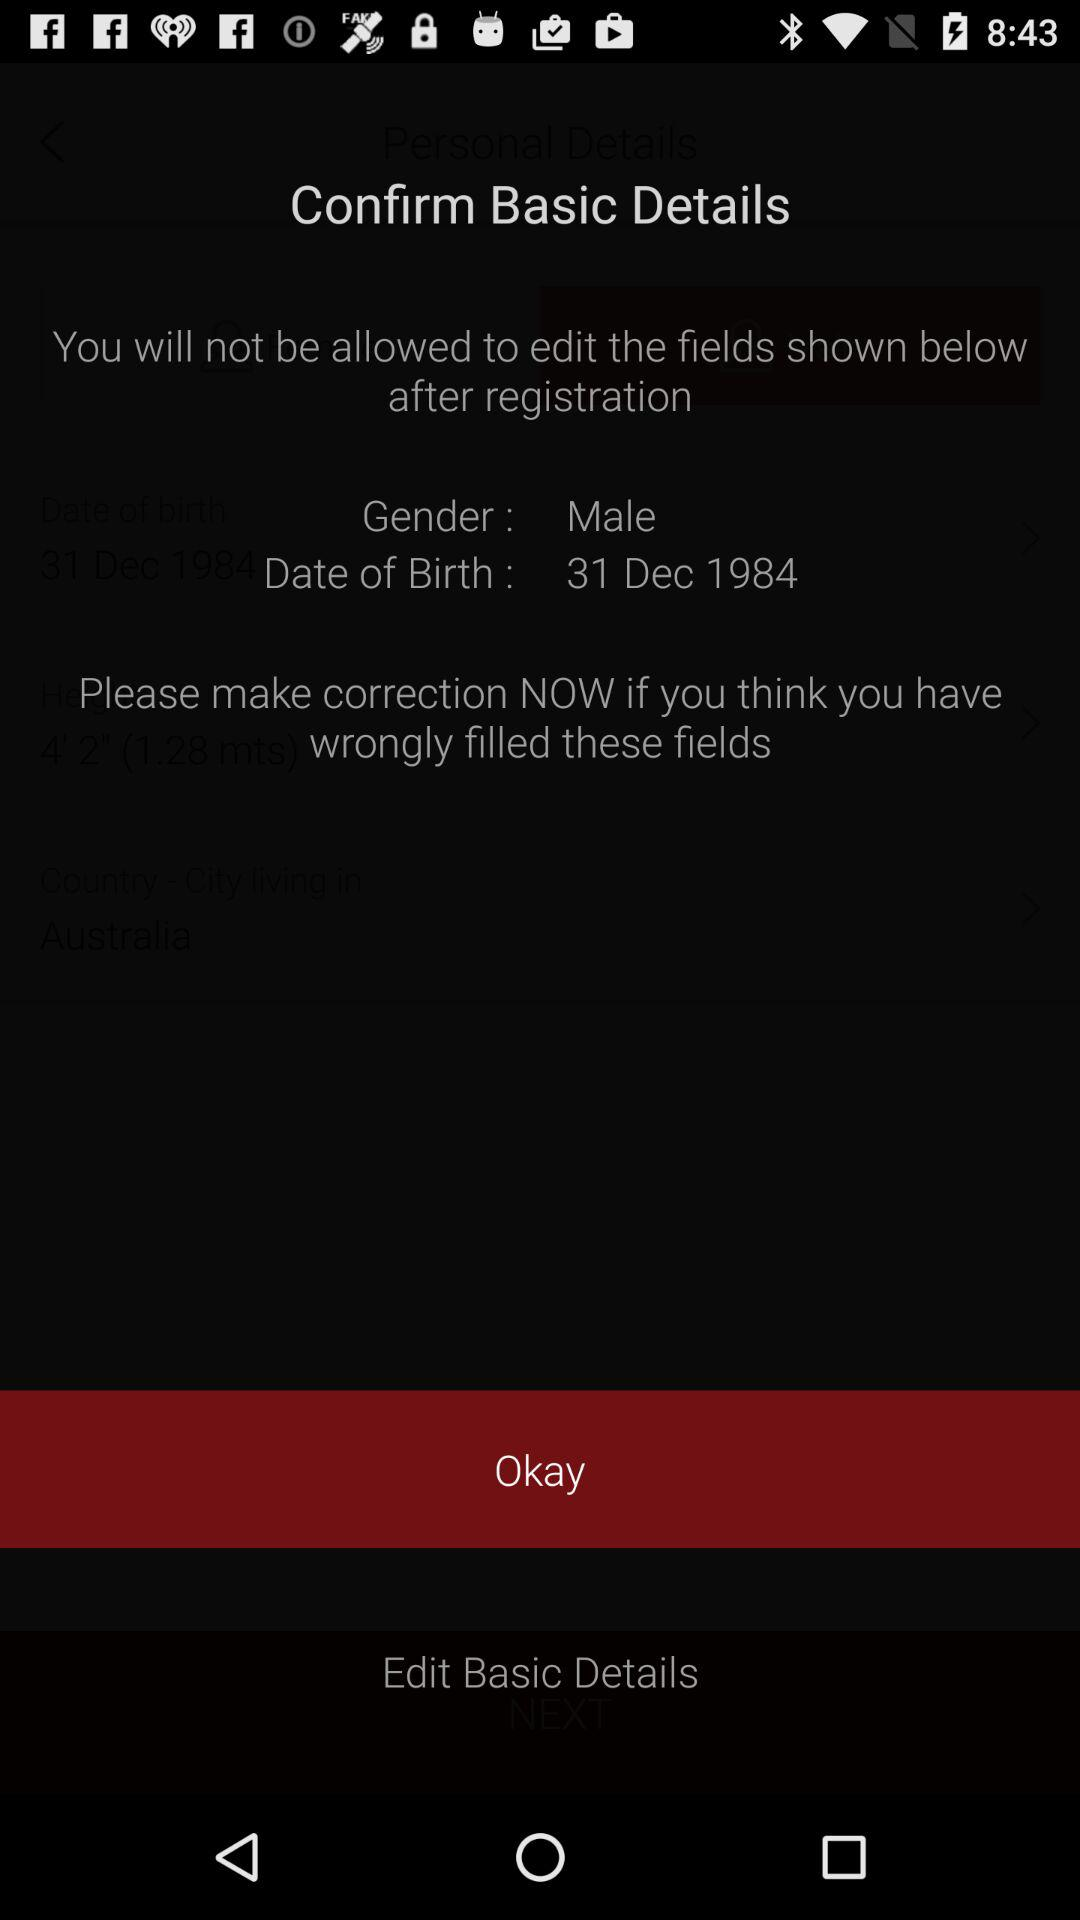How many fields are there that cannot be edited after registration?
Answer the question using a single word or phrase. 2 